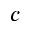<formula> <loc_0><loc_0><loc_500><loc_500>c</formula> 